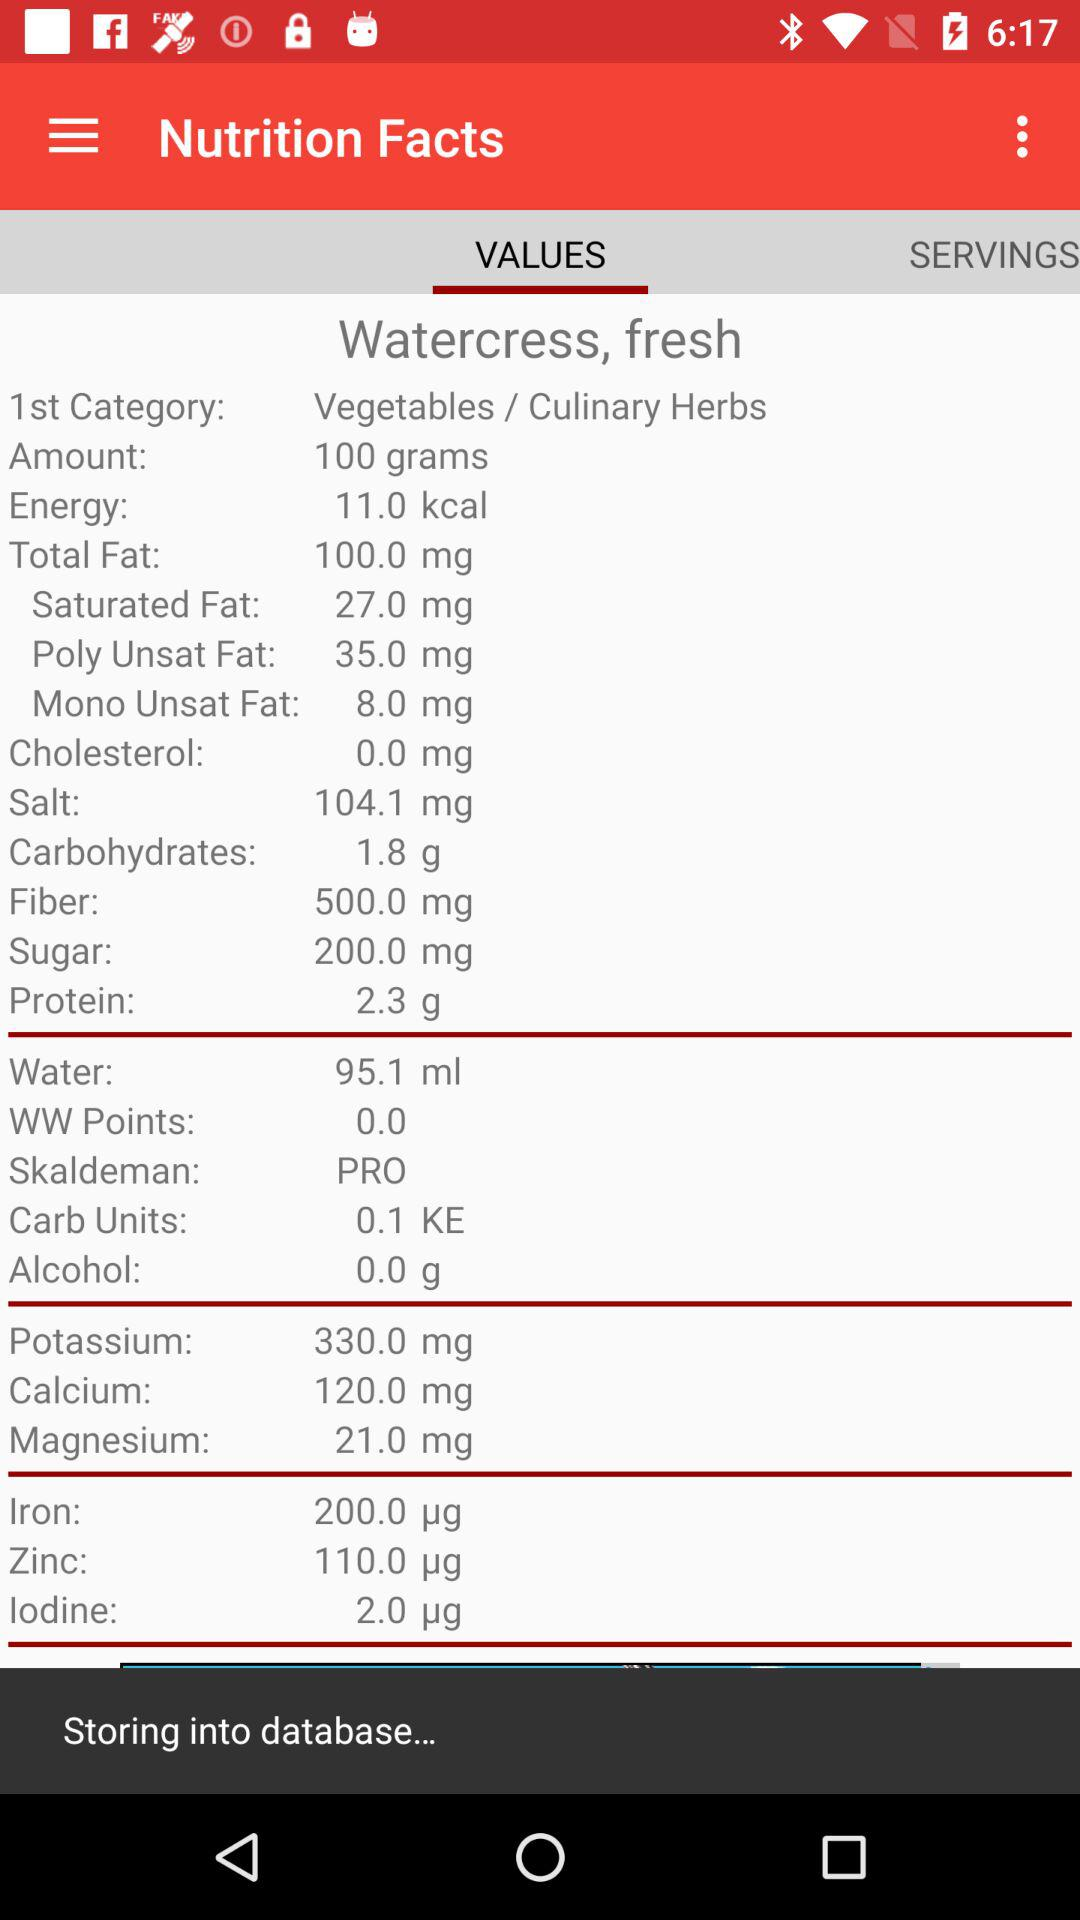How many more mg of potassium are in watercress than in calcium?
Answer the question using a single word or phrase. 210.0 